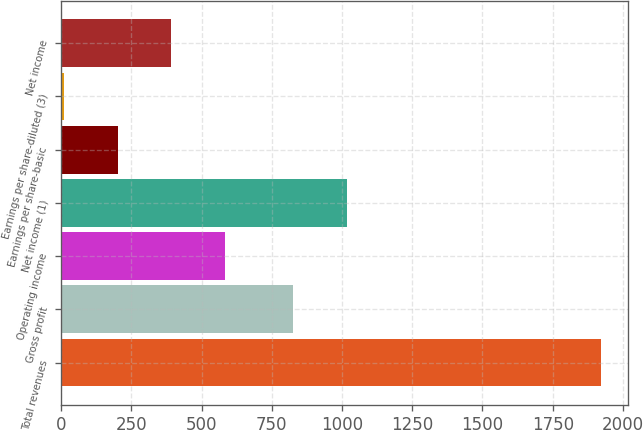<chart> <loc_0><loc_0><loc_500><loc_500><bar_chart><fcel>Total revenues<fcel>Gross profit<fcel>Operating income<fcel>Net income (1)<fcel>Earnings per share-basic<fcel>Earnings per share-diluted (3)<fcel>Net income<nl><fcel>1922<fcel>827<fcel>583.9<fcel>1018.15<fcel>201.6<fcel>10.45<fcel>392.75<nl></chart> 